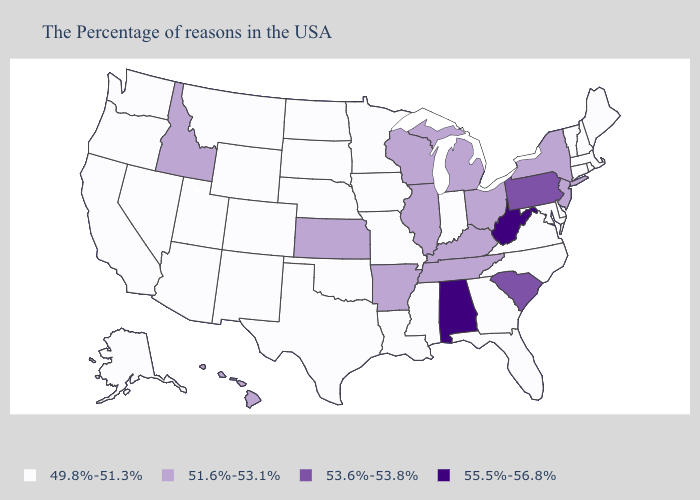What is the value of North Dakota?
Concise answer only. 49.8%-51.3%. Name the states that have a value in the range 53.6%-53.8%?
Write a very short answer. Pennsylvania, South Carolina. What is the lowest value in the Northeast?
Quick response, please. 49.8%-51.3%. What is the lowest value in the USA?
Keep it brief. 49.8%-51.3%. What is the value of New York?
Write a very short answer. 51.6%-53.1%. Name the states that have a value in the range 53.6%-53.8%?
Answer briefly. Pennsylvania, South Carolina. Name the states that have a value in the range 49.8%-51.3%?
Answer briefly. Maine, Massachusetts, Rhode Island, New Hampshire, Vermont, Connecticut, Delaware, Maryland, Virginia, North Carolina, Florida, Georgia, Indiana, Mississippi, Louisiana, Missouri, Minnesota, Iowa, Nebraska, Oklahoma, Texas, South Dakota, North Dakota, Wyoming, Colorado, New Mexico, Utah, Montana, Arizona, Nevada, California, Washington, Oregon, Alaska. Is the legend a continuous bar?
Write a very short answer. No. What is the value of Colorado?
Give a very brief answer. 49.8%-51.3%. Among the states that border California , which have the highest value?
Short answer required. Arizona, Nevada, Oregon. What is the highest value in states that border Arizona?
Answer briefly. 49.8%-51.3%. Name the states that have a value in the range 49.8%-51.3%?
Be succinct. Maine, Massachusetts, Rhode Island, New Hampshire, Vermont, Connecticut, Delaware, Maryland, Virginia, North Carolina, Florida, Georgia, Indiana, Mississippi, Louisiana, Missouri, Minnesota, Iowa, Nebraska, Oklahoma, Texas, South Dakota, North Dakota, Wyoming, Colorado, New Mexico, Utah, Montana, Arizona, Nevada, California, Washington, Oregon, Alaska. Name the states that have a value in the range 51.6%-53.1%?
Quick response, please. New York, New Jersey, Ohio, Michigan, Kentucky, Tennessee, Wisconsin, Illinois, Arkansas, Kansas, Idaho, Hawaii. Does Iowa have the highest value in the MidWest?
Concise answer only. No. Does Oklahoma have the lowest value in the South?
Keep it brief. Yes. 